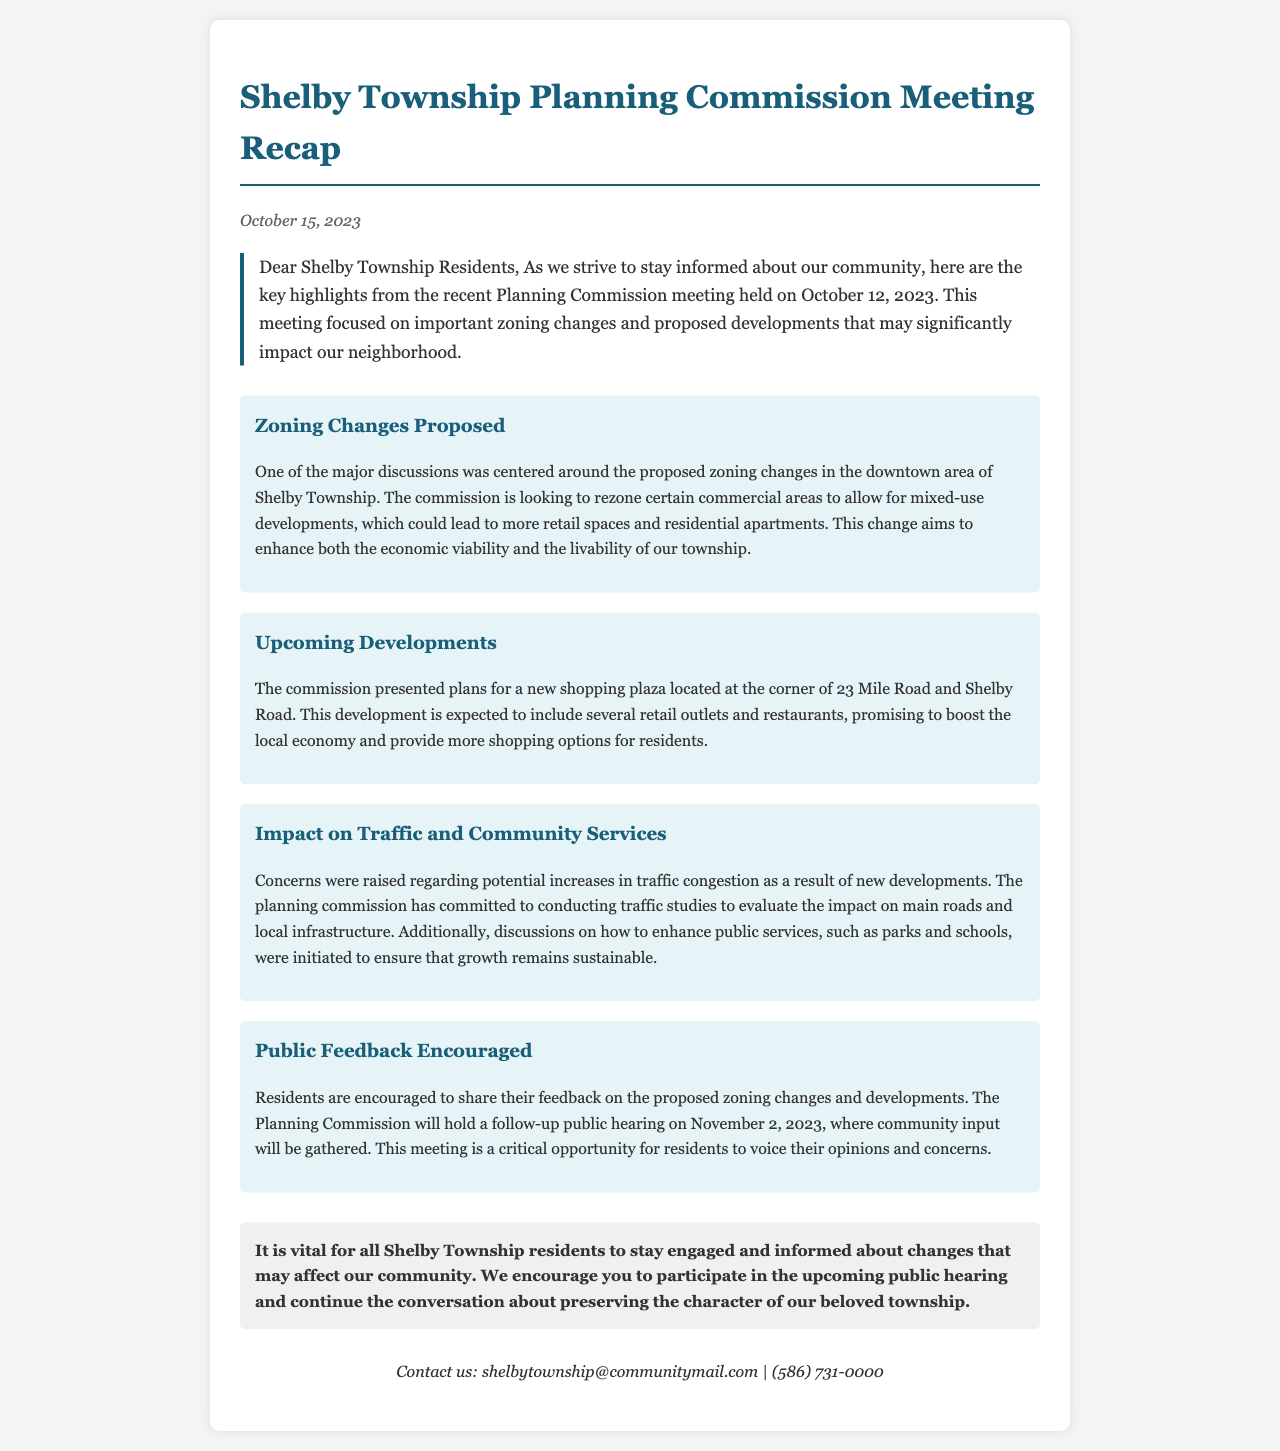what is the date of the meeting? The date of the meeting was mentioned in the document as October 12, 2023.
Answer: October 12, 2023 what proposed zoning change was discussed? The document states that the proposed zoning change was to allow for mixed-use developments in the downtown area.
Answer: mixed-use developments where is the new shopping plaza located? The location for the new shopping plaza is specified as the corner of 23 Mile Road and Shelby Road.
Answer: corner of 23 Mile Road and Shelby Road when is the follow-up public hearing scheduled? The follow-up public hearing date is indicated as November 2, 2023.
Answer: November 2, 2023 what type of feedback is encouraged from residents? The document encourages feedback on proposed zoning changes and developments from the residents.
Answer: proposed zoning changes and developments why are traffic studies being conducted? Traffic studies are being conducted to evaluate the potential increases in traffic congestion due to new developments.
Answer: potential increases in traffic congestion what was one of the main focuses of the Planning Commission meeting? One main focus of the meeting was on zoning changes in the downtown area of Shelby Township.
Answer: zoning changes how are residents encouraged to participate in the process? Residents are encouraged to participate by attending the follow-up public hearing to voice their opinions and concerns.
Answer: by attending the follow-up public hearing 